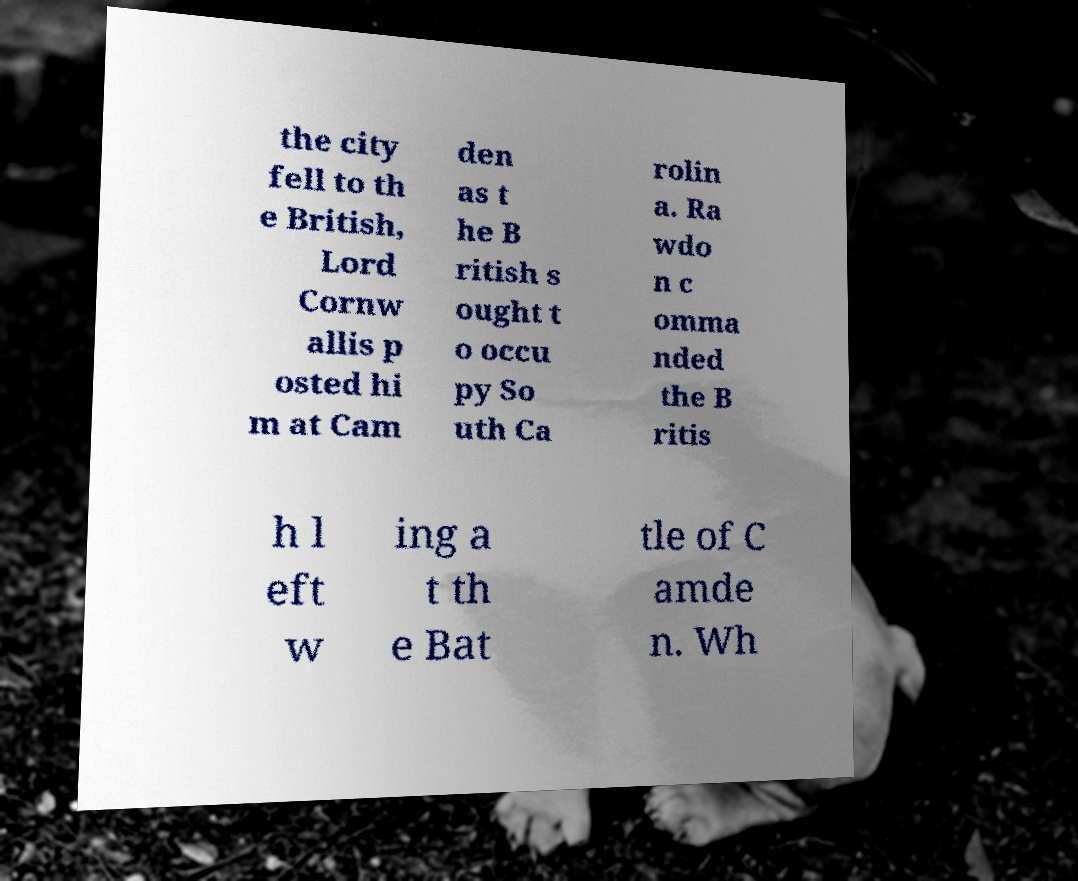I need the written content from this picture converted into text. Can you do that? the city fell to th e British, Lord Cornw allis p osted hi m at Cam den as t he B ritish s ought t o occu py So uth Ca rolin a. Ra wdo n c omma nded the B ritis h l eft w ing a t th e Bat tle of C amde n. Wh 